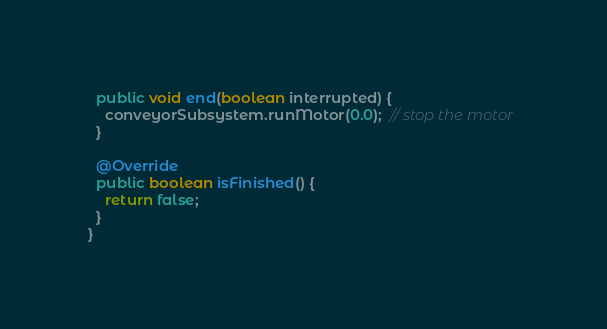Convert code to text. <code><loc_0><loc_0><loc_500><loc_500><_Java_>  public void end(boolean interrupted) {
    conveyorSubsystem.runMotor(0.0);  // stop the motor
  }

  @Override
  public boolean isFinished() {
    return false;
  }
}
</code> 